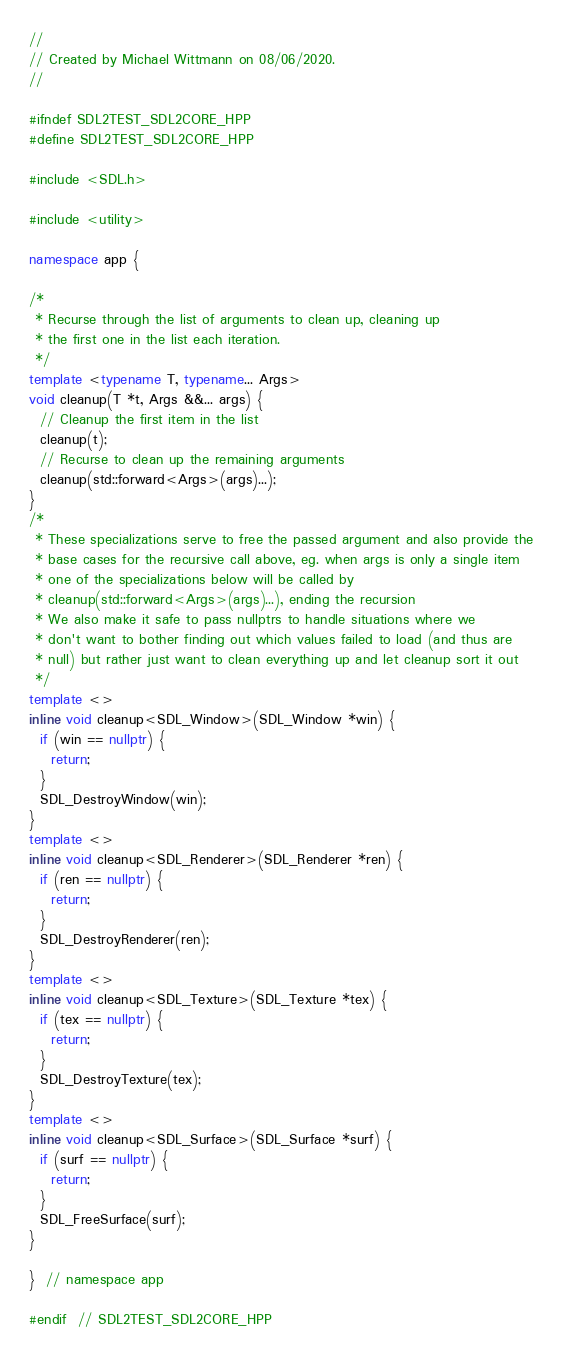Convert code to text. <code><loc_0><loc_0><loc_500><loc_500><_C++_>//
// Created by Michael Wittmann on 08/06/2020.
//

#ifndef SDL2TEST_SDL2CORE_HPP
#define SDL2TEST_SDL2CORE_HPP

#include <SDL.h>

#include <utility>

namespace app {

/*
 * Recurse through the list of arguments to clean up, cleaning up
 * the first one in the list each iteration.
 */
template <typename T, typename... Args>
void cleanup(T *t, Args &&... args) {
  // Cleanup the first item in the list
  cleanup(t);
  // Recurse to clean up the remaining arguments
  cleanup(std::forward<Args>(args)...);
}
/*
 * These specializations serve to free the passed argument and also provide the
 * base cases for the recursive call above, eg. when args is only a single item
 * one of the specializations below will be called by
 * cleanup(std::forward<Args>(args)...), ending the recursion
 * We also make it safe to pass nullptrs to handle situations where we
 * don't want to bother finding out which values failed to load (and thus are
 * null) but rather just want to clean everything up and let cleanup sort it out
 */
template <>
inline void cleanup<SDL_Window>(SDL_Window *win) {
  if (win == nullptr) {
    return;
  }
  SDL_DestroyWindow(win);
}
template <>
inline void cleanup<SDL_Renderer>(SDL_Renderer *ren) {
  if (ren == nullptr) {
    return;
  }
  SDL_DestroyRenderer(ren);
}
template <>
inline void cleanup<SDL_Texture>(SDL_Texture *tex) {
  if (tex == nullptr) {
    return;
  }
  SDL_DestroyTexture(tex);
}
template <>
inline void cleanup<SDL_Surface>(SDL_Surface *surf) {
  if (surf == nullptr) {
    return;
  }
  SDL_FreeSurface(surf);
}

}  // namespace app

#endif  // SDL2TEST_SDL2CORE_HPP
</code> 